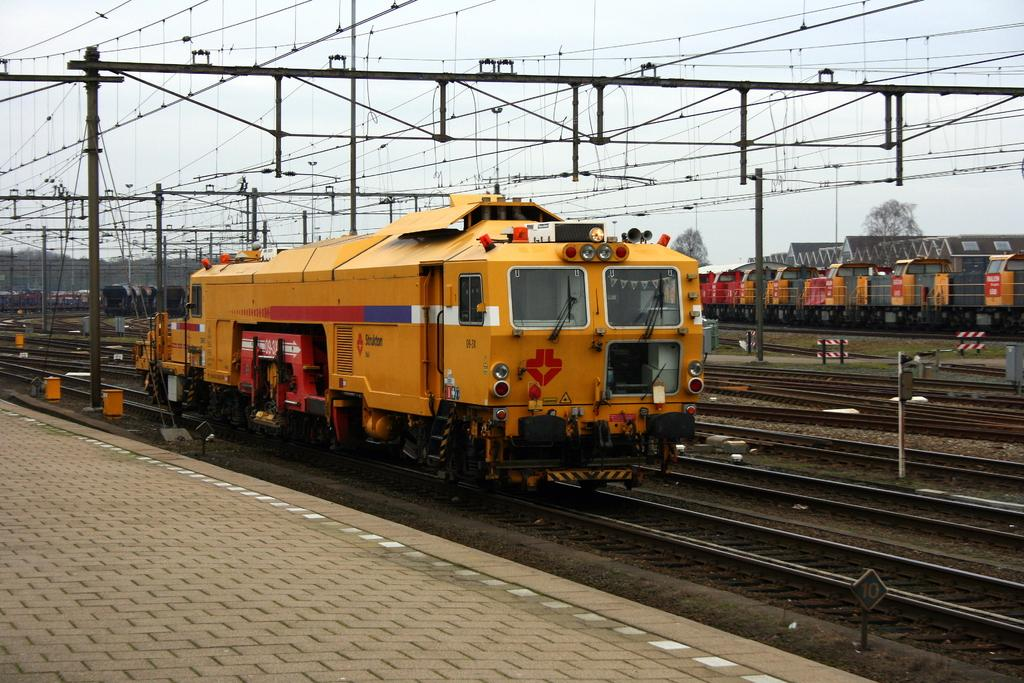What is the main subject of the image? The main subject of the image is trains. What is the setting for the trains in the image? There is a railway track in the image, which is the setting for the trains. What type of vegetation can be seen in the image? There are trees in the image. What else is present in the image besides the trains and trees? There are current poles in the image. What is visible in the background of the image? The sky is visible in the image. What title is given to the word "selection" in the image? There is no word "selection" present in the image, so it is not possible to determine a title for it. 